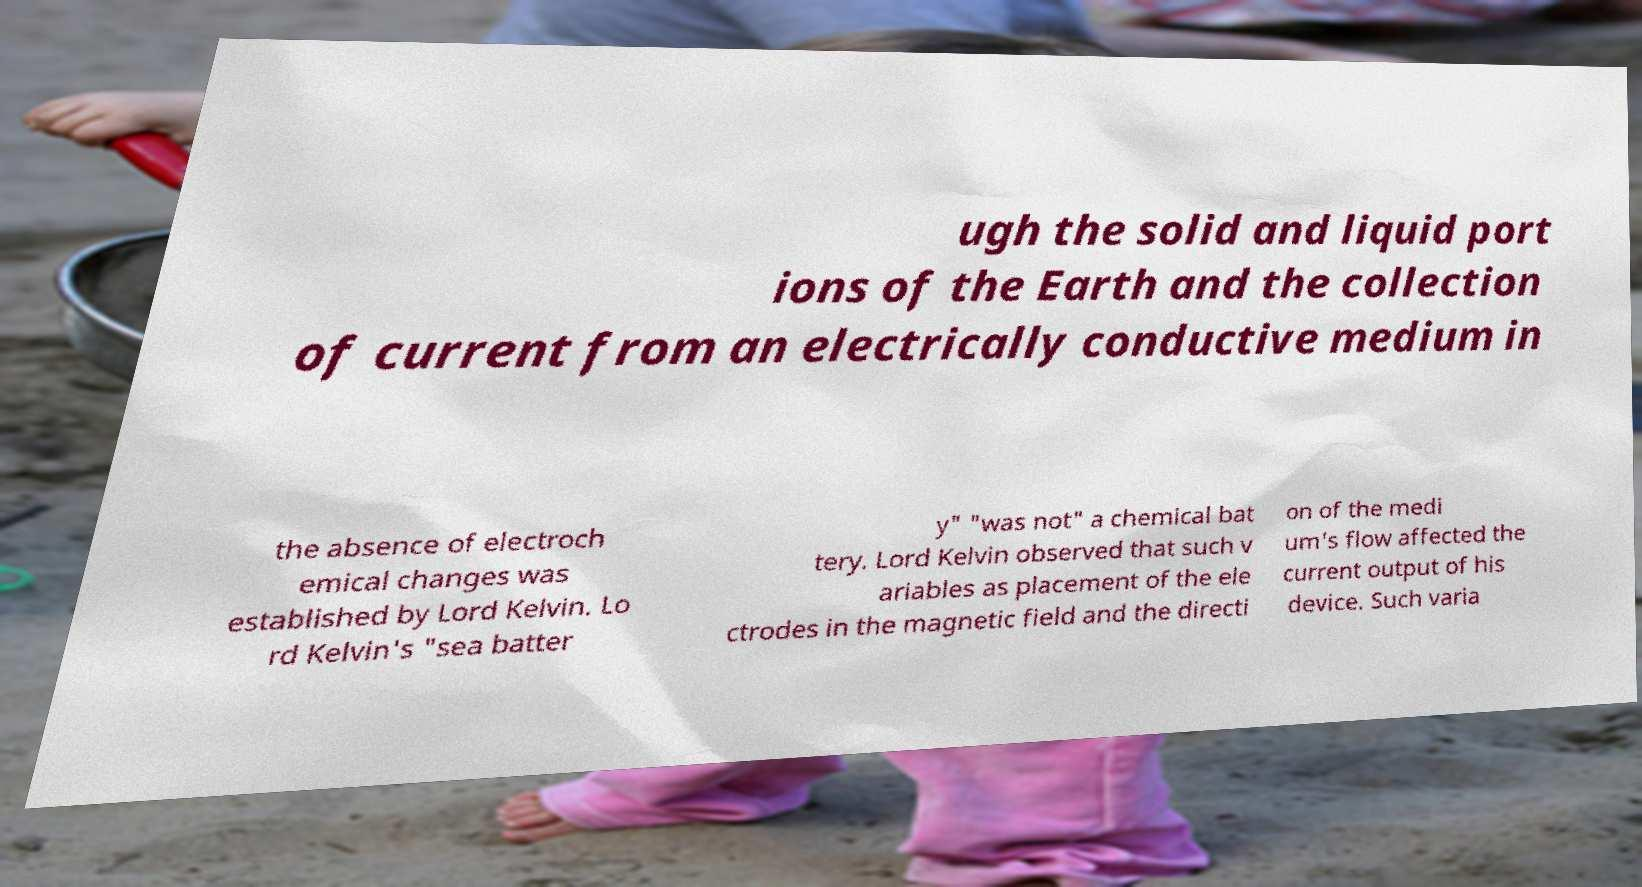Please read and relay the text visible in this image. What does it say? ugh the solid and liquid port ions of the Earth and the collection of current from an electrically conductive medium in the absence of electroch emical changes was established by Lord Kelvin. Lo rd Kelvin's "sea batter y" "was not" a chemical bat tery. Lord Kelvin observed that such v ariables as placement of the ele ctrodes in the magnetic field and the directi on of the medi um's flow affected the current output of his device. Such varia 